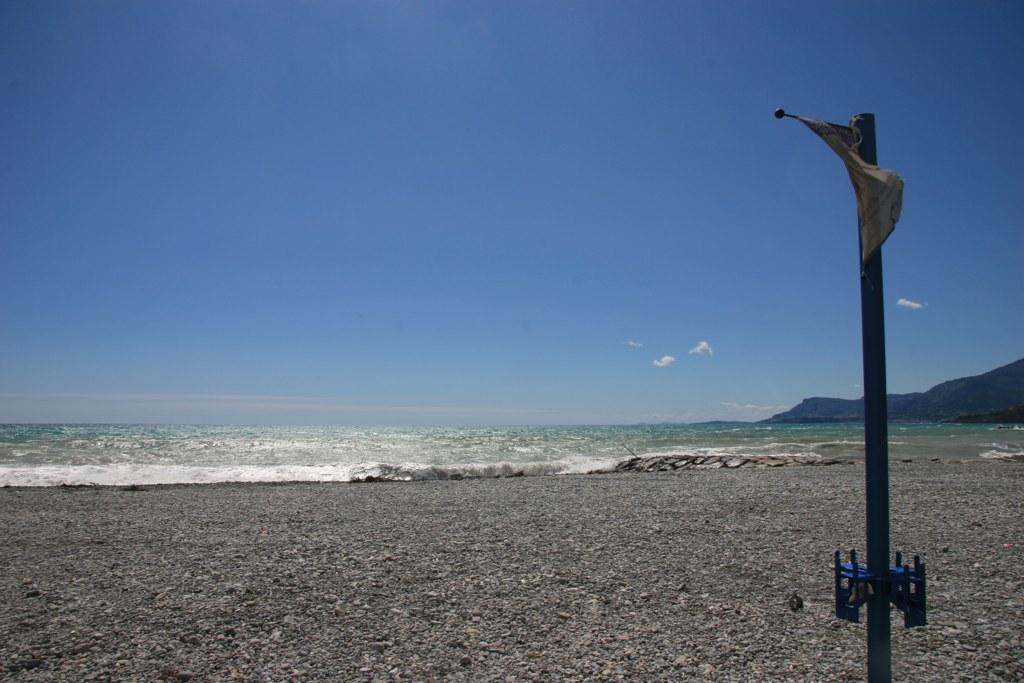What is attached to the pole in the image? There is a flag attached to the pole in the image. What can be seen in the image besides the pole and flag? Water and hills are visible in the image. What is visible in the background of the image? The sky is visible in the background of the image. Where is the bathtub located in the image? There is no bathtub present in the image. What type of tub is visible in the image? There is no tub present in the image. 